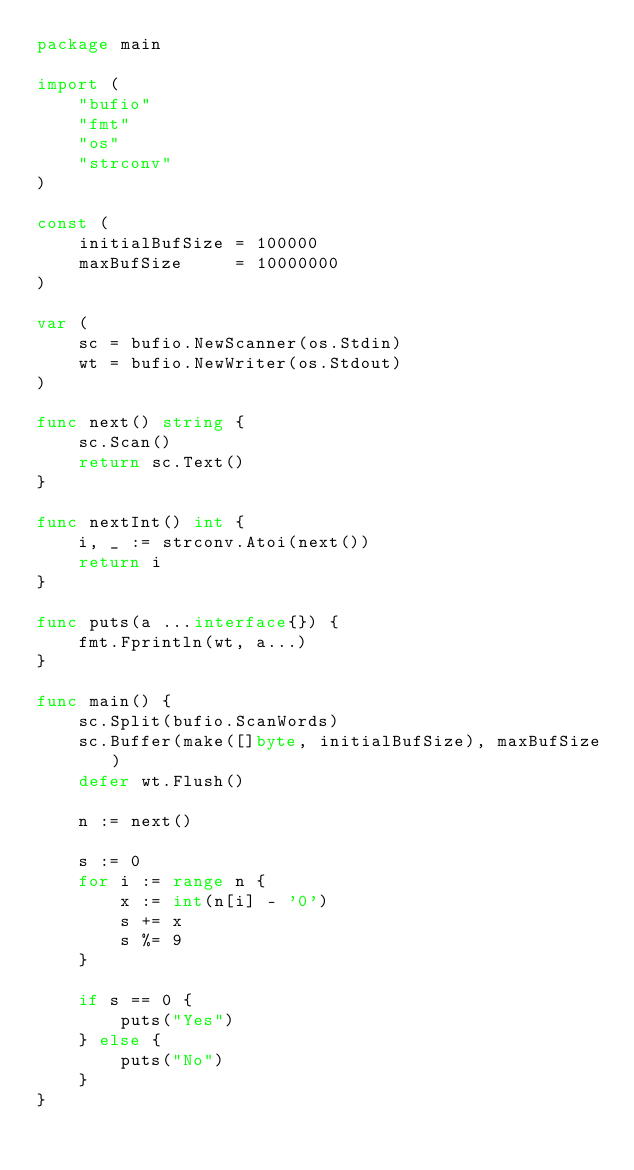<code> <loc_0><loc_0><loc_500><loc_500><_Go_>package main

import (
	"bufio"
	"fmt"
	"os"
	"strconv"
)

const (
	initialBufSize = 100000
	maxBufSize     = 10000000
)

var (
	sc = bufio.NewScanner(os.Stdin)
	wt = bufio.NewWriter(os.Stdout)
)

func next() string {
	sc.Scan()
	return sc.Text()
}

func nextInt() int {
	i, _ := strconv.Atoi(next())
	return i
}

func puts(a ...interface{}) {
	fmt.Fprintln(wt, a...)
}

func main() {
	sc.Split(bufio.ScanWords)
	sc.Buffer(make([]byte, initialBufSize), maxBufSize)
	defer wt.Flush()

	n := next()

	s := 0
	for i := range n {
		x := int(n[i] - '0')
		s += x
		s %= 9
	}

	if s == 0 {
		puts("Yes")
	} else {
		puts("No")
	}
}
</code> 